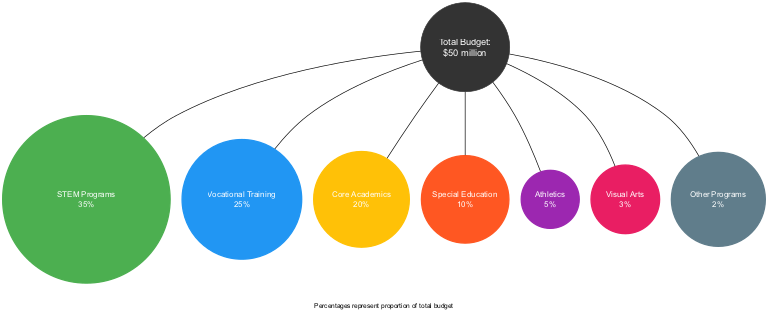What percentage of the total budget is allocated to STEM Programs? The diagram shows that STEM Programs have a section labeled with a percentage value. According to the provided data, this segment represents 35% of the total budget.
Answer: 35% What is the budget allocation for Visual Arts? The diagram indicates that Visual Arts is one of the segments and its corresponding section shows the percentage allocation which is stated as 3%.
Answer: 3% Which program has the highest percentage of budget allocation? By examining all the segments, it is clear that STEM Programs, with 35%, has the highest allocation compared to other programs.
Answer: STEM Programs What is the combined percentage of funding for Vocational Training and Core Academics? To find the combined percentage, add the percentages of both Vocational Training (25%) and Core Academics (20%). This results in a total of 25% + 20% = 45%.
Answer: 45% What is the total percentage allocated to Special Education and Athletics combined? The percentage for Special Education is 10%, and for Athletics, it is 5%. Adding them together gives 10% + 5% = 15%.
Answer: 15% How many total segments are represented in the diagram? Each educational program is represented as a segment in the diagram. Counting all the distinct segments listed, there are 7 total segments.
Answer: 7 Which program has the least funding based on the pie chart? By reviewing the segments, it is evident that Other Programs has the lowest allocation with a percentage of 2%.
Answer: Other Programs What color represents Vocational Training in the diagram? The color associated with Vocational Training is displayed alongside its segment and is provided in the data. It is specified as #2196F3.
Answer: #2196F3 What percentage of the total budget is allocated to Core Academics? The diagram indicates the allocation for Core Academics directly labeled next to its segment, which is 20%.
Answer: 20% 